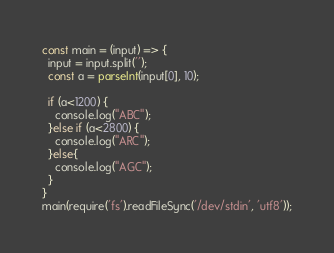Convert code to text. <code><loc_0><loc_0><loc_500><loc_500><_TypeScript_>const main = (input) => {
  input = input.split('');
  const a = parseInt(input[0], 10);
  
  if (a<1200) {
    console.log("ABC");
  }else if (a<2800) {
    console.log("ARC");
  }else{
    console.log("AGC");
  }
}
main(require('fs').readFileSync('/dev/stdin', 'utf8'));</code> 